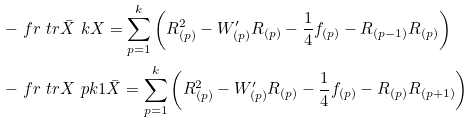<formula> <loc_0><loc_0><loc_500><loc_500>- & \ f r \ t r \bar { X } \ k X = \sum _ { p = 1 } ^ { k } \left ( R _ { ( p ) } ^ { 2 } - W ^ { \prime } _ { ( p ) } R _ { ( p ) } - \frac { 1 } { 4 } f _ { ( p ) } - R _ { ( p - 1 ) } R _ { ( p ) } \right ) \\ - & \ f r \ t r X \ p k 1 \bar { X } = \sum _ { p = 1 } ^ { k } \left ( R _ { ( p ) } ^ { 2 } - W ^ { \prime } _ { ( p ) } R _ { ( p ) } - \frac { 1 } { 4 } f _ { ( p ) } - R _ { ( p ) } R _ { ( p + 1 ) } \right )</formula> 